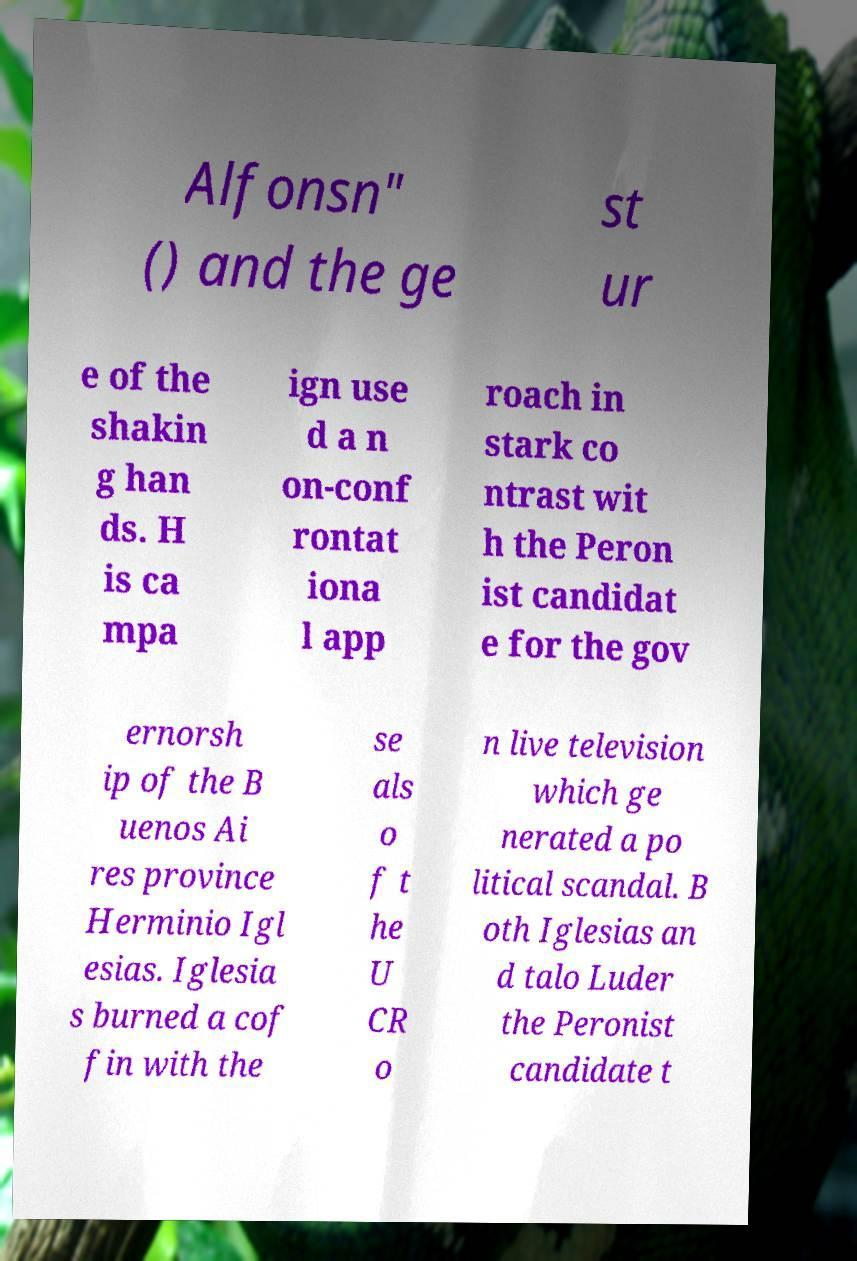Could you assist in decoding the text presented in this image and type it out clearly? Alfonsn" () and the ge st ur e of the shakin g han ds. H is ca mpa ign use d a n on-conf rontat iona l app roach in stark co ntrast wit h the Peron ist candidat e for the gov ernorsh ip of the B uenos Ai res province Herminio Igl esias. Iglesia s burned a cof fin with the se als o f t he U CR o n live television which ge nerated a po litical scandal. B oth Iglesias an d talo Luder the Peronist candidate t 